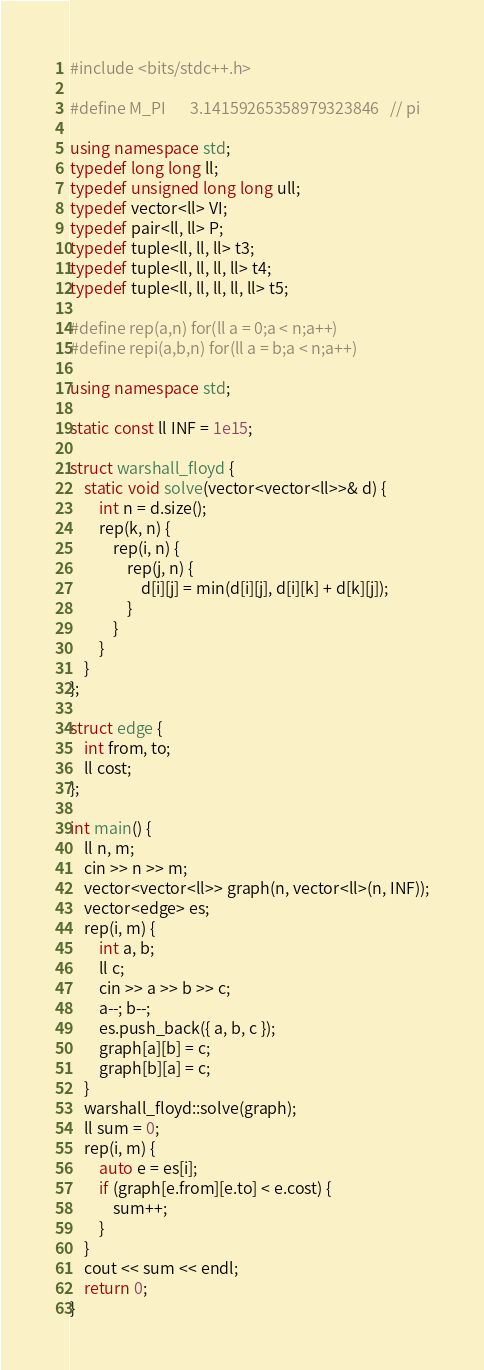<code> <loc_0><loc_0><loc_500><loc_500><_C++_>#include <bits/stdc++.h>

#define M_PI       3.14159265358979323846   // pi

using namespace std;
typedef long long ll;
typedef unsigned long long ull;
typedef vector<ll> VI;
typedef pair<ll, ll> P;
typedef tuple<ll, ll, ll> t3;
typedef tuple<ll, ll, ll, ll> t4;
typedef tuple<ll, ll, ll, ll, ll> t5;

#define rep(a,n) for(ll a = 0;a < n;a++)
#define repi(a,b,n) for(ll a = b;a < n;a++)

using namespace std;

static const ll INF = 1e15;

struct warshall_floyd {
	static void solve(vector<vector<ll>>& d) {
		int n = d.size();
		rep(k, n) {
			rep(i, n) {
				rep(j, n) {
					d[i][j] = min(d[i][j], d[i][k] + d[k][j]);
				}
			}
		}
	}
};

struct edge {
	int from, to;
	ll cost;
};

int main() {
	ll n, m;
	cin >> n >> m;
	vector<vector<ll>> graph(n, vector<ll>(n, INF));
	vector<edge> es;
	rep(i, m) {
		int a, b;
		ll c;
		cin >> a >> b >> c;
		a--; b--;
		es.push_back({ a, b, c });
		graph[a][b] = c;
		graph[b][a] = c;
	}
	warshall_floyd::solve(graph);
	ll sum = 0;
	rep(i, m) {
		auto e = es[i];
		if (graph[e.from][e.to] < e.cost) {
			sum++;
		}
	}
	cout << sum << endl;
	return 0;
}
</code> 